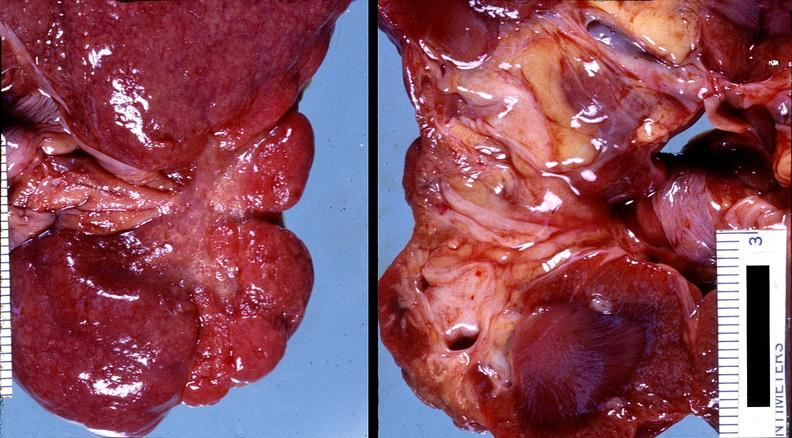what does this image show?
Answer the question using a single word or phrase. Kidney 